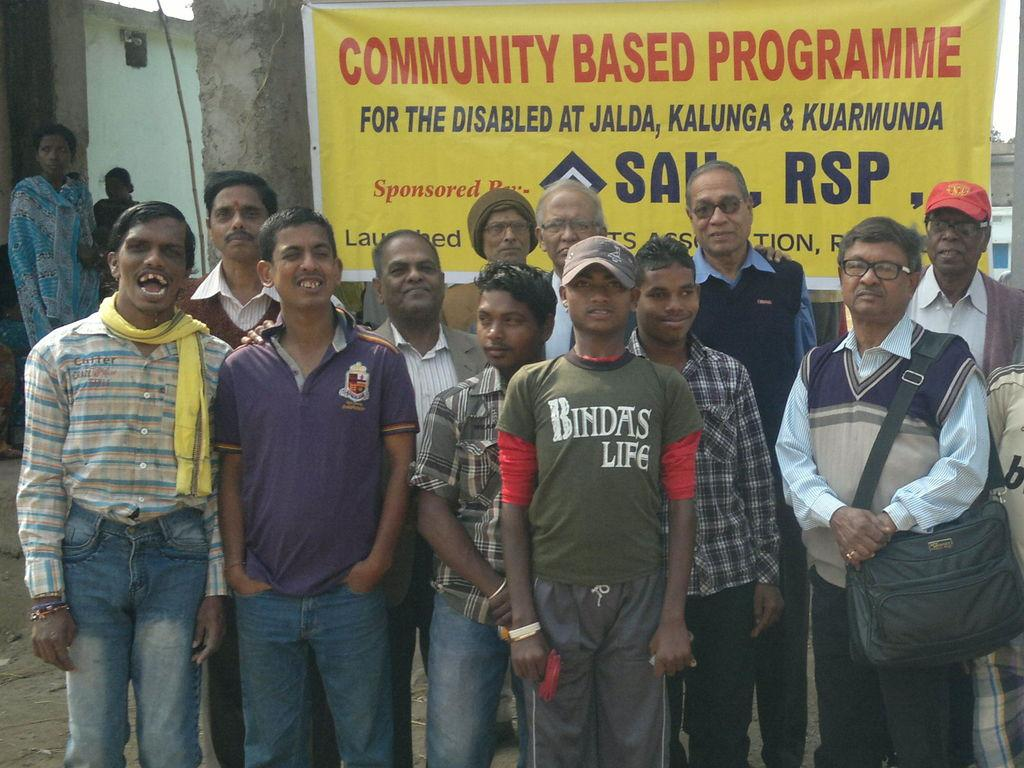How many people are in the image? There are people in the image, but the exact number is not specified. Can you describe the person on the right side of the image? There is a person wearing a bag on the right side of the image. What can be seen in the background of the image? There is a banner and a wall in the background of the image. What type of furniture is being used by the person wearing a stocking in the image? There is no person wearing a stocking in the image, and therefore no furniture can be associated with that person. 